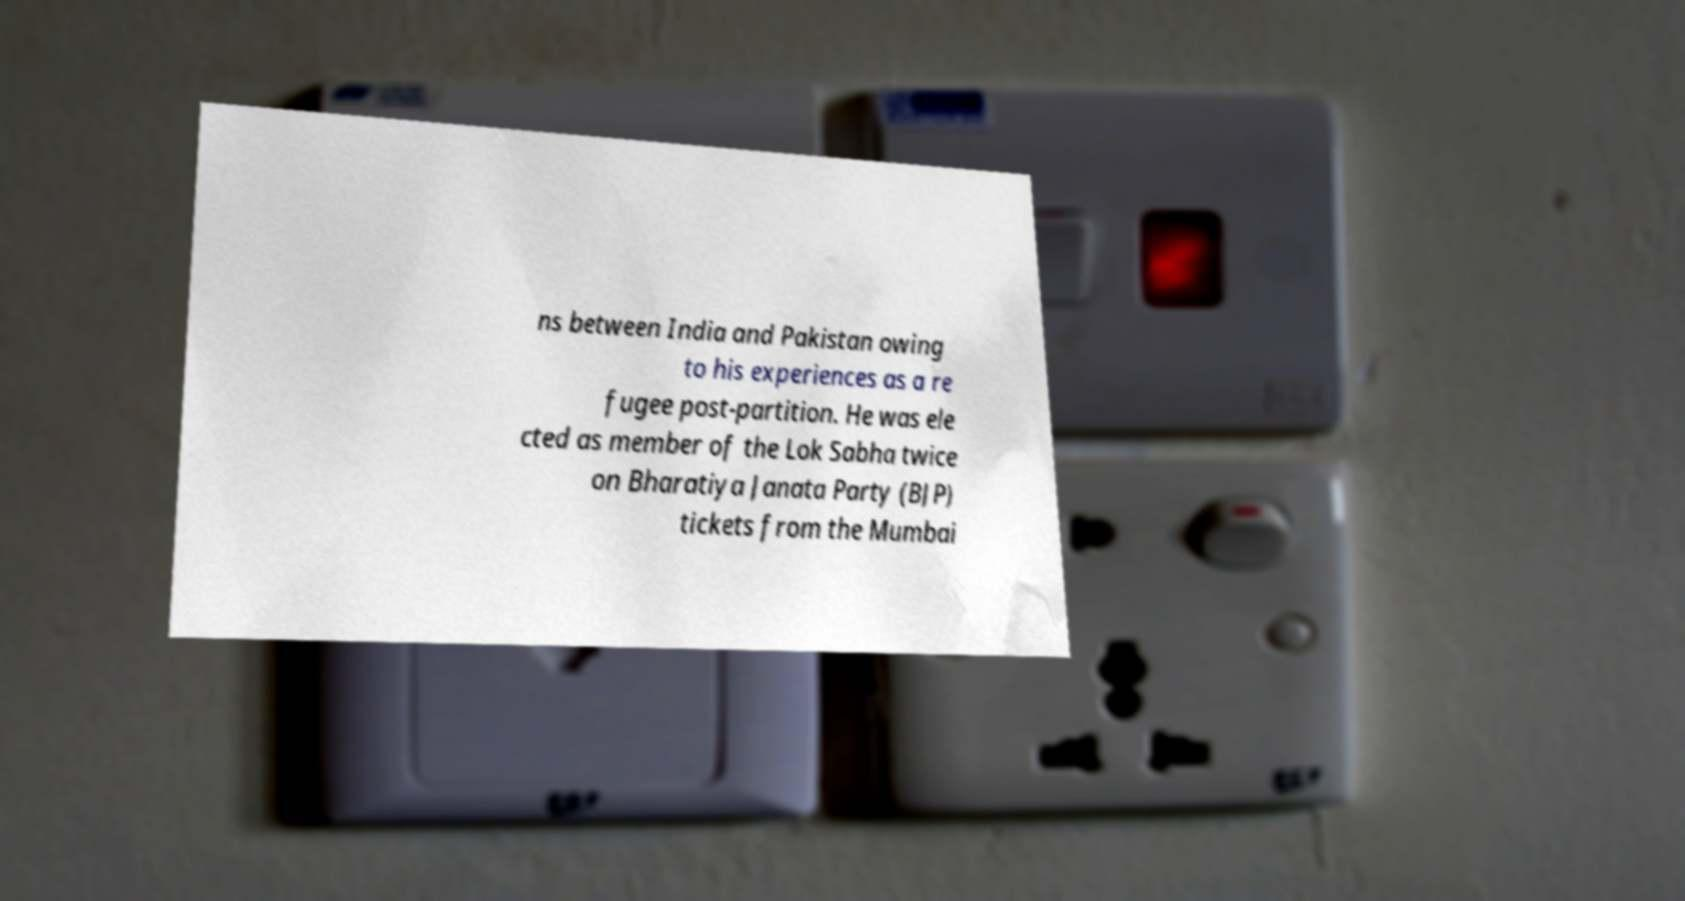What messages or text are displayed in this image? I need them in a readable, typed format. ns between India and Pakistan owing to his experiences as a re fugee post-partition. He was ele cted as member of the Lok Sabha twice on Bharatiya Janata Party (BJP) tickets from the Mumbai 